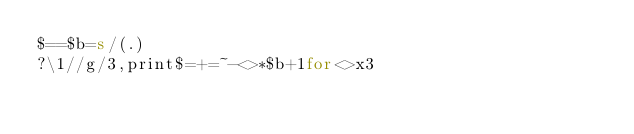<code> <loc_0><loc_0><loc_500><loc_500><_Perl_>$==$b=s/(.)
?\1//g/3,print$=+=~-<>*$b+1for<>x3</code> 